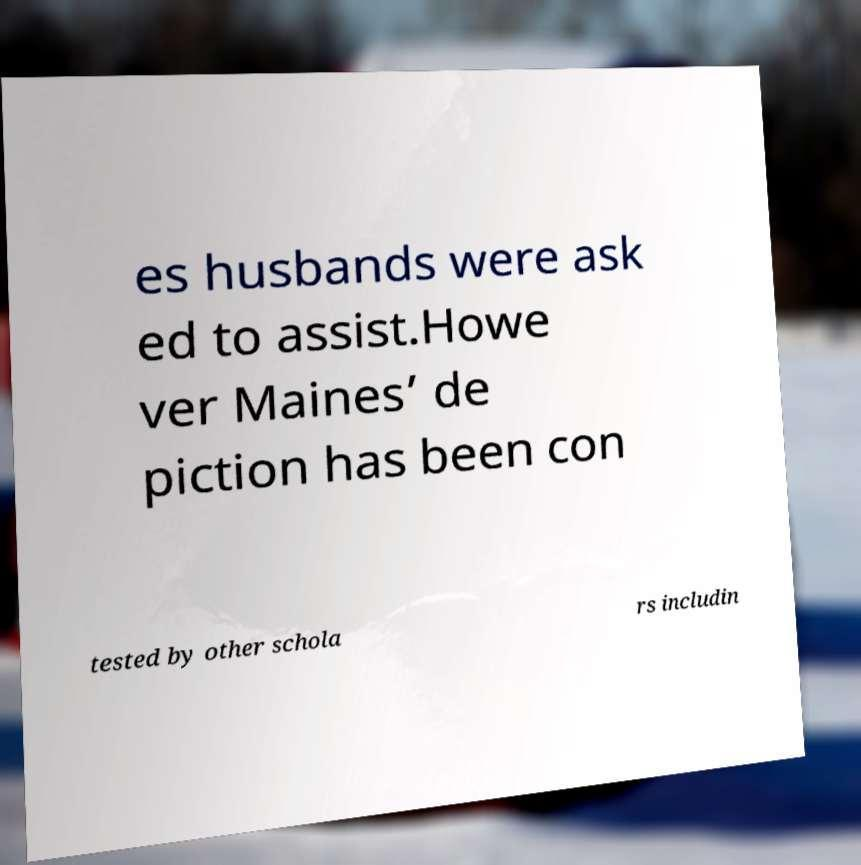What messages or text are displayed in this image? I need them in a readable, typed format. es husbands were ask ed to assist.Howe ver Maines’ de piction has been con tested by other schola rs includin 